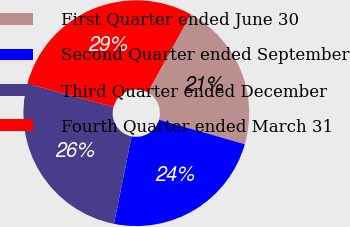Convert chart to OTSL. <chart><loc_0><loc_0><loc_500><loc_500><pie_chart><fcel>First Quarter ended June 30<fcel>Second Quarter ended September<fcel>Third Quarter ended December<fcel>Fourth Quarter ended March 31<nl><fcel>21.41%<fcel>23.73%<fcel>26.05%<fcel>28.81%<nl></chart> 